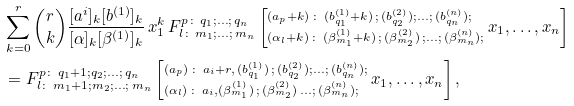<formula> <loc_0><loc_0><loc_500><loc_500>& \sum _ { k = 0 } ^ { r } { r \choose k } \frac { [ a ^ { i } ] _ { k } [ b ^ { ( 1 ) } ] _ { k } } { [ \alpha ] _ { k } [ \beta ^ { ( 1 ) } ] _ { k } } \, x _ { 1 } ^ { k } \, F _ { { l } \colon \, m _ { 1 } ; \dots ; \, m _ { n } } ^ { p \colon \, q _ { 1 } ; \dots ; \, q _ { n } } \left [ ^ { ( a _ { p } + k ) \, \colon \, ( b ^ { ( 1 ) } _ { q _ { 1 } } + k ) \, ; \, ( b ^ { ( 2 ) } _ { q _ { 2 } } ) ; \dots ; \, ( b ^ { ( n ) } _ { q _ { n } } ) ; } _ { ( \alpha _ { l } + k ) \, \colon \, ( \beta ^ { ( 1 ) } _ { m _ { 1 } } + k ) \, ; \, ( \beta ^ { ( 2 ) } _ { m _ { 2 } } ) \, ; \dots ; \, ( \beta ^ { ( n ) } _ { m _ { n } } ) ; } \, x _ { 1 } , \dots , x _ { n } \right ] \\ & = F _ { { l } \colon \, m _ { 1 } + 1 ; m _ { 2 } ; \dots ; \, m _ { n } } ^ { p \colon \, q _ { 1 } + 1 ; q _ { 2 } ; \dots ; \, q _ { n } } \left [ ^ { ( a _ { p } ) \, \colon \, a _ { i } + r , \, ( b ^ { ( 1 ) } _ { q _ { 1 } } ) \, ; \, ( b ^ { ( 2 ) } _ { q _ { 2 } } ) ; \dots ; \, ( b ^ { ( n ) } _ { q _ { n } } ) ; } _ { ( \alpha _ { l } ) \, \colon \, a _ { i } , ( \beta ^ { ( 1 ) } _ { m _ { 1 } } ) \, ; \, ( \beta ^ { ( 2 ) } _ { m _ { 2 } } ) \, \dots ; \, ( \beta ^ { ( n ) } _ { m _ { n } } ) ; } \, x _ { 1 } , \dots , x _ { n } \right ] ,</formula> 